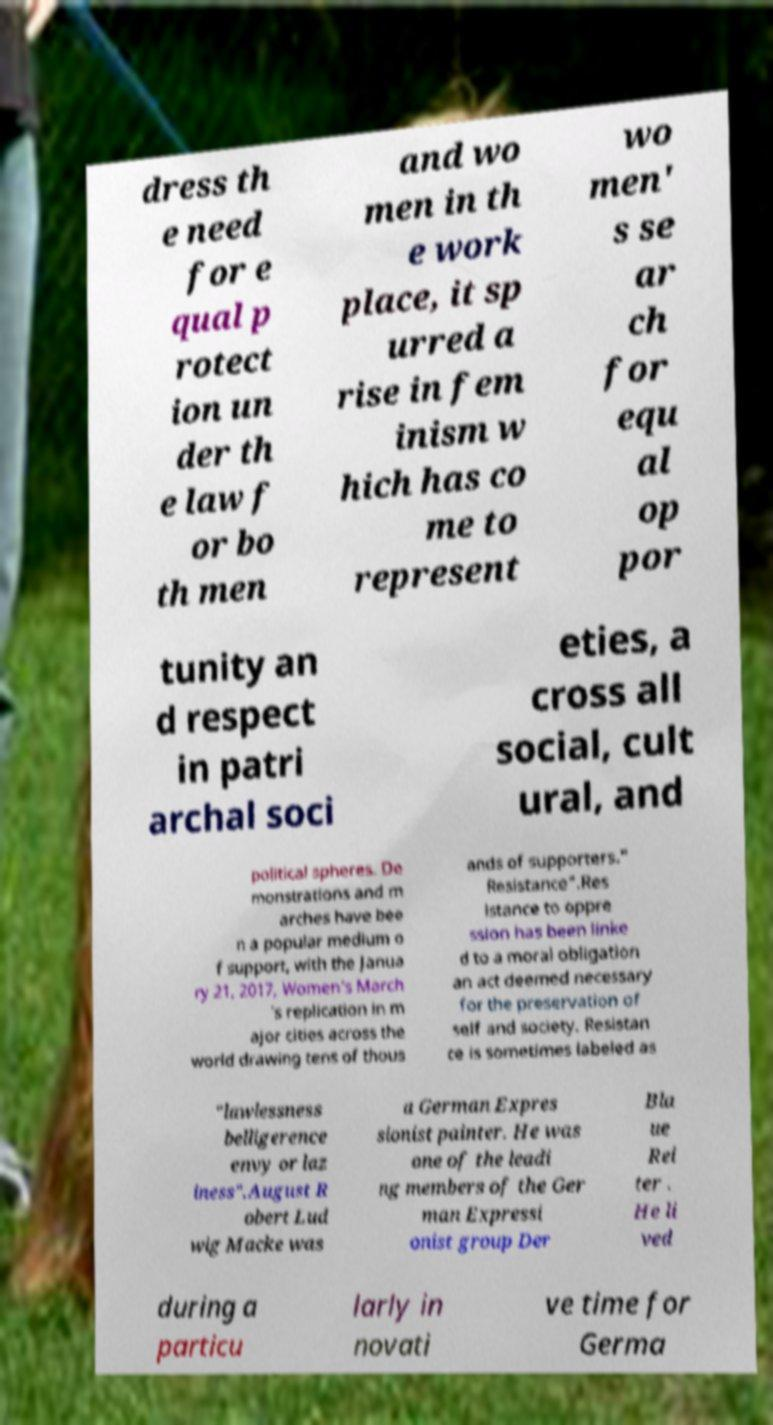What messages or text are displayed in this image? I need them in a readable, typed format. dress th e need for e qual p rotect ion un der th e law f or bo th men and wo men in th e work place, it sp urred a rise in fem inism w hich has co me to represent wo men' s se ar ch for equ al op por tunity an d respect in patri archal soci eties, a cross all social, cult ural, and political spheres. De monstrations and m arches have bee n a popular medium o f support, with the Janua ry 21, 2017, Women's March 's replication in m ajor cities across the world drawing tens of thous ands of supporters." Resistance".Res istance to oppre ssion has been linke d to a moral obligation an act deemed necessary for the preservation of self and society. Resistan ce is sometimes labeled as "lawlessness belligerence envy or laz iness".August R obert Lud wig Macke was a German Expres sionist painter. He was one of the leadi ng members of the Ger man Expressi onist group Der Bla ue Rei ter . He li ved during a particu larly in novati ve time for Germa 